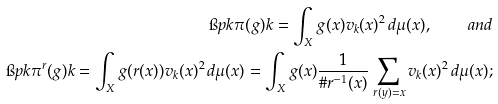<formula> <loc_0><loc_0><loc_500><loc_500>\i p { k } { \pi ( g ) k } = \int _ { X } g ( x ) v _ { k } ( x ) ^ { 2 } \, d \mu ( x ) , \quad a n d \\ \i p { k } { \pi ^ { r } ( g ) k } = \int _ { X } g ( r ( x ) ) v _ { k } ( x ) ^ { 2 } \, d \mu ( x ) = \int _ { X } g ( x ) \frac { 1 } { \# r ^ { - 1 } ( x ) } \sum _ { r ( y ) = x } v _ { k } ( x ) ^ { 2 } \, d \mu ( x ) ;</formula> 